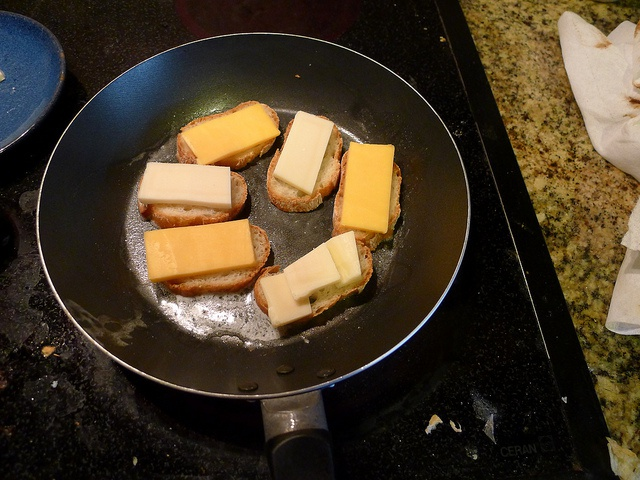Describe the objects in this image and their specific colors. I can see oven in black, orange, tan, and maroon tones, sandwich in black, tan, and olive tones, sandwich in black, orange, olive, and maroon tones, sandwich in black, tan, and brown tones, and sandwich in black, tan, and olive tones in this image. 